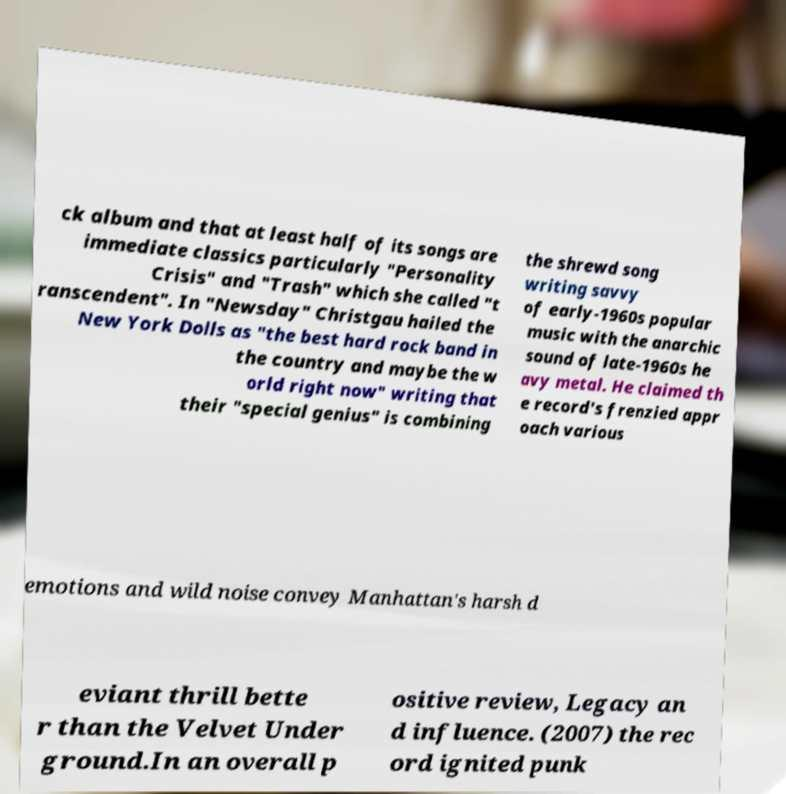Can you read and provide the text displayed in the image?This photo seems to have some interesting text. Can you extract and type it out for me? ck album and that at least half of its songs are immediate classics particularly "Personality Crisis" and "Trash" which she called "t ranscendent". In "Newsday" Christgau hailed the New York Dolls as "the best hard rock band in the country and maybe the w orld right now" writing that their "special genius" is combining the shrewd song writing savvy of early-1960s popular music with the anarchic sound of late-1960s he avy metal. He claimed th e record's frenzied appr oach various emotions and wild noise convey Manhattan's harsh d eviant thrill bette r than the Velvet Under ground.In an overall p ositive review, Legacy an d influence. (2007) the rec ord ignited punk 